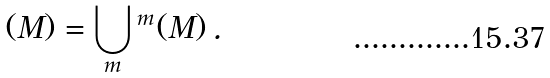Convert formula to latex. <formula><loc_0><loc_0><loc_500><loc_500>\AA ( M ) = \bigcup _ { m } \AA ^ { m } ( M ) \, .</formula> 